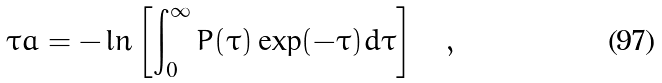Convert formula to latex. <formula><loc_0><loc_0><loc_500><loc_500>\tau a = - \ln \left [ \int _ { 0 } ^ { \infty } P ( \tau ) \exp ( - \tau ) d \tau \right ] \quad ,</formula> 